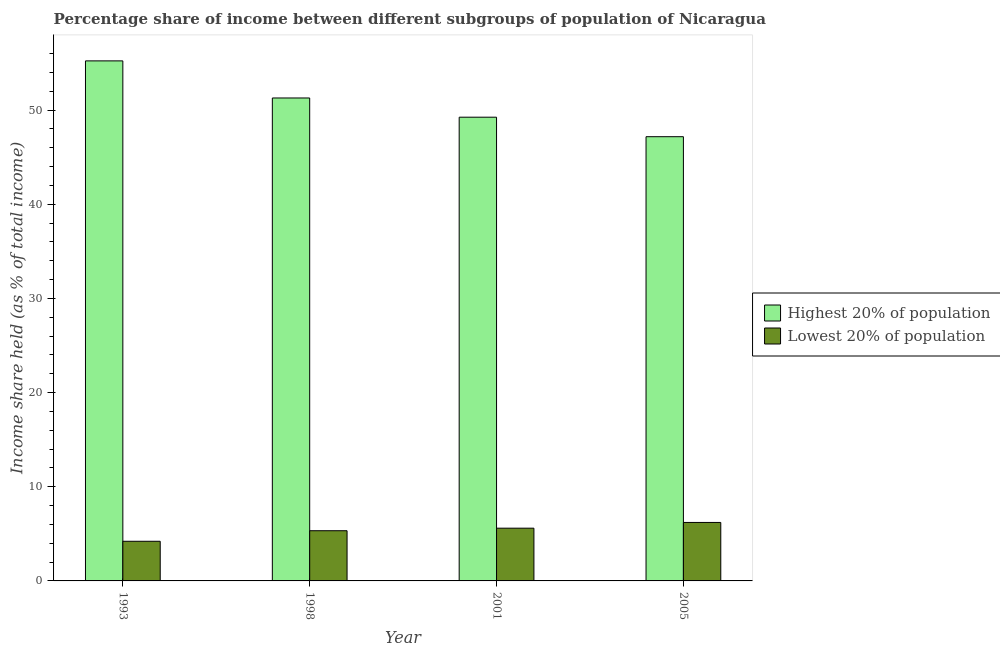Are the number of bars per tick equal to the number of legend labels?
Make the answer very short. Yes. Are the number of bars on each tick of the X-axis equal?
Provide a short and direct response. Yes. How many bars are there on the 4th tick from the left?
Provide a succinct answer. 2. How many bars are there on the 1st tick from the right?
Offer a very short reply. 2. In how many cases, is the number of bars for a given year not equal to the number of legend labels?
Keep it short and to the point. 0. What is the income share held by highest 20% of the population in 2001?
Make the answer very short. 49.24. Across all years, what is the maximum income share held by lowest 20% of the population?
Make the answer very short. 6.21. Across all years, what is the minimum income share held by highest 20% of the population?
Your answer should be compact. 47.17. In which year was the income share held by lowest 20% of the population maximum?
Provide a short and direct response. 2005. What is the total income share held by lowest 20% of the population in the graph?
Your answer should be very brief. 21.35. What is the difference between the income share held by lowest 20% of the population in 1993 and that in 2005?
Your answer should be compact. -2. What is the difference between the income share held by lowest 20% of the population in 2001 and the income share held by highest 20% of the population in 1998?
Your answer should be compact. 0.27. What is the average income share held by highest 20% of the population per year?
Make the answer very short. 50.73. In the year 2001, what is the difference between the income share held by lowest 20% of the population and income share held by highest 20% of the population?
Make the answer very short. 0. What is the ratio of the income share held by highest 20% of the population in 1993 to that in 1998?
Your response must be concise. 1.08. What is the difference between the highest and the second highest income share held by highest 20% of the population?
Give a very brief answer. 3.94. What is the difference between the highest and the lowest income share held by highest 20% of the population?
Your answer should be compact. 8.05. In how many years, is the income share held by highest 20% of the population greater than the average income share held by highest 20% of the population taken over all years?
Your response must be concise. 2. What does the 2nd bar from the left in 2001 represents?
Keep it short and to the point. Lowest 20% of population. What does the 1st bar from the right in 1993 represents?
Your answer should be very brief. Lowest 20% of population. How many bars are there?
Provide a short and direct response. 8. Are all the bars in the graph horizontal?
Your answer should be compact. No. What is the difference between two consecutive major ticks on the Y-axis?
Ensure brevity in your answer.  10. Does the graph contain any zero values?
Keep it short and to the point. No. Where does the legend appear in the graph?
Offer a very short reply. Center right. How are the legend labels stacked?
Provide a succinct answer. Vertical. What is the title of the graph?
Provide a succinct answer. Percentage share of income between different subgroups of population of Nicaragua. Does "GDP" appear as one of the legend labels in the graph?
Your answer should be very brief. No. What is the label or title of the X-axis?
Provide a succinct answer. Year. What is the label or title of the Y-axis?
Offer a terse response. Income share held (as % of total income). What is the Income share held (as % of total income) of Highest 20% of population in 1993?
Offer a very short reply. 55.22. What is the Income share held (as % of total income) in Lowest 20% of population in 1993?
Keep it short and to the point. 4.21. What is the Income share held (as % of total income) in Highest 20% of population in 1998?
Your response must be concise. 51.28. What is the Income share held (as % of total income) of Lowest 20% of population in 1998?
Ensure brevity in your answer.  5.33. What is the Income share held (as % of total income) in Highest 20% of population in 2001?
Keep it short and to the point. 49.24. What is the Income share held (as % of total income) in Lowest 20% of population in 2001?
Your answer should be compact. 5.6. What is the Income share held (as % of total income) of Highest 20% of population in 2005?
Give a very brief answer. 47.17. What is the Income share held (as % of total income) in Lowest 20% of population in 2005?
Your answer should be very brief. 6.21. Across all years, what is the maximum Income share held (as % of total income) in Highest 20% of population?
Offer a terse response. 55.22. Across all years, what is the maximum Income share held (as % of total income) in Lowest 20% of population?
Make the answer very short. 6.21. Across all years, what is the minimum Income share held (as % of total income) of Highest 20% of population?
Your response must be concise. 47.17. Across all years, what is the minimum Income share held (as % of total income) of Lowest 20% of population?
Keep it short and to the point. 4.21. What is the total Income share held (as % of total income) of Highest 20% of population in the graph?
Ensure brevity in your answer.  202.91. What is the total Income share held (as % of total income) of Lowest 20% of population in the graph?
Keep it short and to the point. 21.35. What is the difference between the Income share held (as % of total income) of Highest 20% of population in 1993 and that in 1998?
Give a very brief answer. 3.94. What is the difference between the Income share held (as % of total income) of Lowest 20% of population in 1993 and that in 1998?
Your response must be concise. -1.12. What is the difference between the Income share held (as % of total income) of Highest 20% of population in 1993 and that in 2001?
Provide a short and direct response. 5.98. What is the difference between the Income share held (as % of total income) in Lowest 20% of population in 1993 and that in 2001?
Provide a short and direct response. -1.39. What is the difference between the Income share held (as % of total income) of Highest 20% of population in 1993 and that in 2005?
Your answer should be very brief. 8.05. What is the difference between the Income share held (as % of total income) in Lowest 20% of population in 1993 and that in 2005?
Provide a succinct answer. -2. What is the difference between the Income share held (as % of total income) in Highest 20% of population in 1998 and that in 2001?
Offer a terse response. 2.04. What is the difference between the Income share held (as % of total income) of Lowest 20% of population in 1998 and that in 2001?
Offer a very short reply. -0.27. What is the difference between the Income share held (as % of total income) in Highest 20% of population in 1998 and that in 2005?
Provide a short and direct response. 4.11. What is the difference between the Income share held (as % of total income) of Lowest 20% of population in 1998 and that in 2005?
Provide a succinct answer. -0.88. What is the difference between the Income share held (as % of total income) in Highest 20% of population in 2001 and that in 2005?
Your answer should be very brief. 2.07. What is the difference between the Income share held (as % of total income) of Lowest 20% of population in 2001 and that in 2005?
Make the answer very short. -0.61. What is the difference between the Income share held (as % of total income) in Highest 20% of population in 1993 and the Income share held (as % of total income) in Lowest 20% of population in 1998?
Provide a succinct answer. 49.89. What is the difference between the Income share held (as % of total income) of Highest 20% of population in 1993 and the Income share held (as % of total income) of Lowest 20% of population in 2001?
Offer a terse response. 49.62. What is the difference between the Income share held (as % of total income) in Highest 20% of population in 1993 and the Income share held (as % of total income) in Lowest 20% of population in 2005?
Offer a terse response. 49.01. What is the difference between the Income share held (as % of total income) in Highest 20% of population in 1998 and the Income share held (as % of total income) in Lowest 20% of population in 2001?
Give a very brief answer. 45.68. What is the difference between the Income share held (as % of total income) in Highest 20% of population in 1998 and the Income share held (as % of total income) in Lowest 20% of population in 2005?
Provide a short and direct response. 45.07. What is the difference between the Income share held (as % of total income) of Highest 20% of population in 2001 and the Income share held (as % of total income) of Lowest 20% of population in 2005?
Keep it short and to the point. 43.03. What is the average Income share held (as % of total income) in Highest 20% of population per year?
Give a very brief answer. 50.73. What is the average Income share held (as % of total income) of Lowest 20% of population per year?
Provide a succinct answer. 5.34. In the year 1993, what is the difference between the Income share held (as % of total income) of Highest 20% of population and Income share held (as % of total income) of Lowest 20% of population?
Provide a succinct answer. 51.01. In the year 1998, what is the difference between the Income share held (as % of total income) in Highest 20% of population and Income share held (as % of total income) in Lowest 20% of population?
Ensure brevity in your answer.  45.95. In the year 2001, what is the difference between the Income share held (as % of total income) of Highest 20% of population and Income share held (as % of total income) of Lowest 20% of population?
Provide a short and direct response. 43.64. In the year 2005, what is the difference between the Income share held (as % of total income) in Highest 20% of population and Income share held (as % of total income) in Lowest 20% of population?
Give a very brief answer. 40.96. What is the ratio of the Income share held (as % of total income) in Highest 20% of population in 1993 to that in 1998?
Offer a terse response. 1.08. What is the ratio of the Income share held (as % of total income) of Lowest 20% of population in 1993 to that in 1998?
Give a very brief answer. 0.79. What is the ratio of the Income share held (as % of total income) of Highest 20% of population in 1993 to that in 2001?
Keep it short and to the point. 1.12. What is the ratio of the Income share held (as % of total income) in Lowest 20% of population in 1993 to that in 2001?
Provide a succinct answer. 0.75. What is the ratio of the Income share held (as % of total income) of Highest 20% of population in 1993 to that in 2005?
Offer a very short reply. 1.17. What is the ratio of the Income share held (as % of total income) of Lowest 20% of population in 1993 to that in 2005?
Provide a short and direct response. 0.68. What is the ratio of the Income share held (as % of total income) in Highest 20% of population in 1998 to that in 2001?
Provide a short and direct response. 1.04. What is the ratio of the Income share held (as % of total income) of Lowest 20% of population in 1998 to that in 2001?
Keep it short and to the point. 0.95. What is the ratio of the Income share held (as % of total income) of Highest 20% of population in 1998 to that in 2005?
Keep it short and to the point. 1.09. What is the ratio of the Income share held (as % of total income) in Lowest 20% of population in 1998 to that in 2005?
Your answer should be very brief. 0.86. What is the ratio of the Income share held (as % of total income) in Highest 20% of population in 2001 to that in 2005?
Give a very brief answer. 1.04. What is the ratio of the Income share held (as % of total income) in Lowest 20% of population in 2001 to that in 2005?
Your answer should be very brief. 0.9. What is the difference between the highest and the second highest Income share held (as % of total income) of Highest 20% of population?
Your answer should be very brief. 3.94. What is the difference between the highest and the second highest Income share held (as % of total income) in Lowest 20% of population?
Your response must be concise. 0.61. What is the difference between the highest and the lowest Income share held (as % of total income) of Highest 20% of population?
Give a very brief answer. 8.05. What is the difference between the highest and the lowest Income share held (as % of total income) in Lowest 20% of population?
Make the answer very short. 2. 